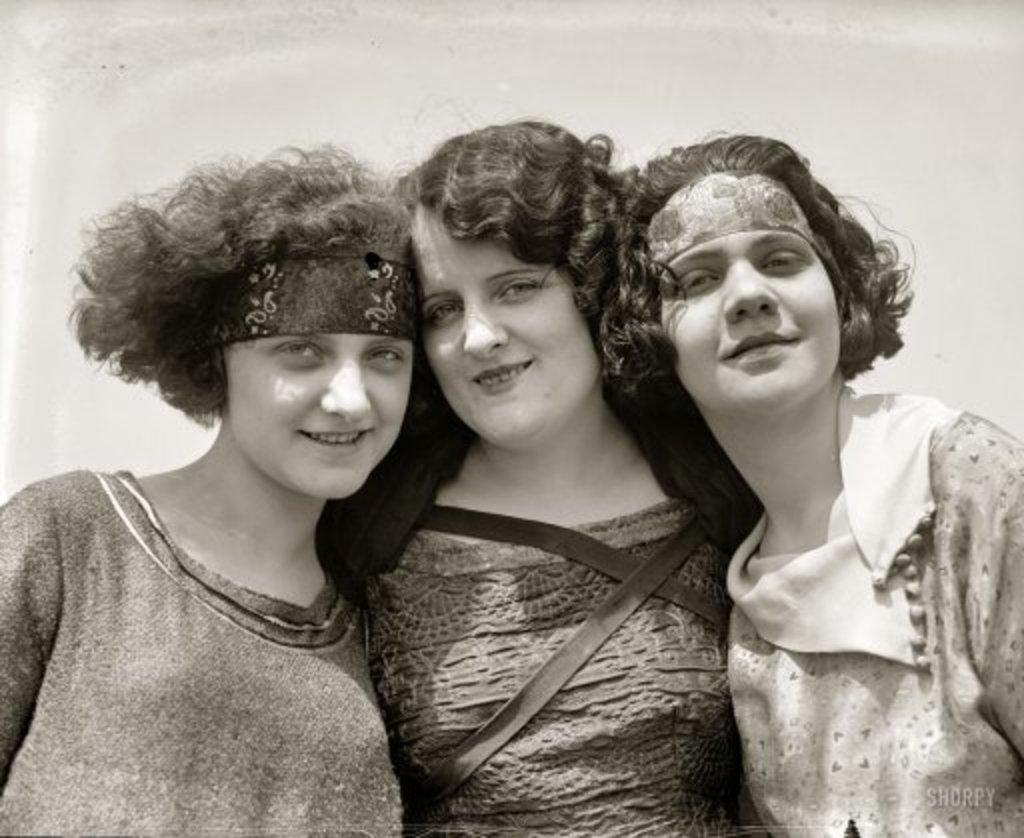What is the color scheme of the image? The image is black and white. How many women are in the middle of the image? There are three women in the middle of the image. What is the facial expression of the women? The women have smiling faces. What type of carpenter tools can be seen in the image? There are no carpenter tools present in the image. Is there a train visible in the background of the image? There is no train visible in the image. 